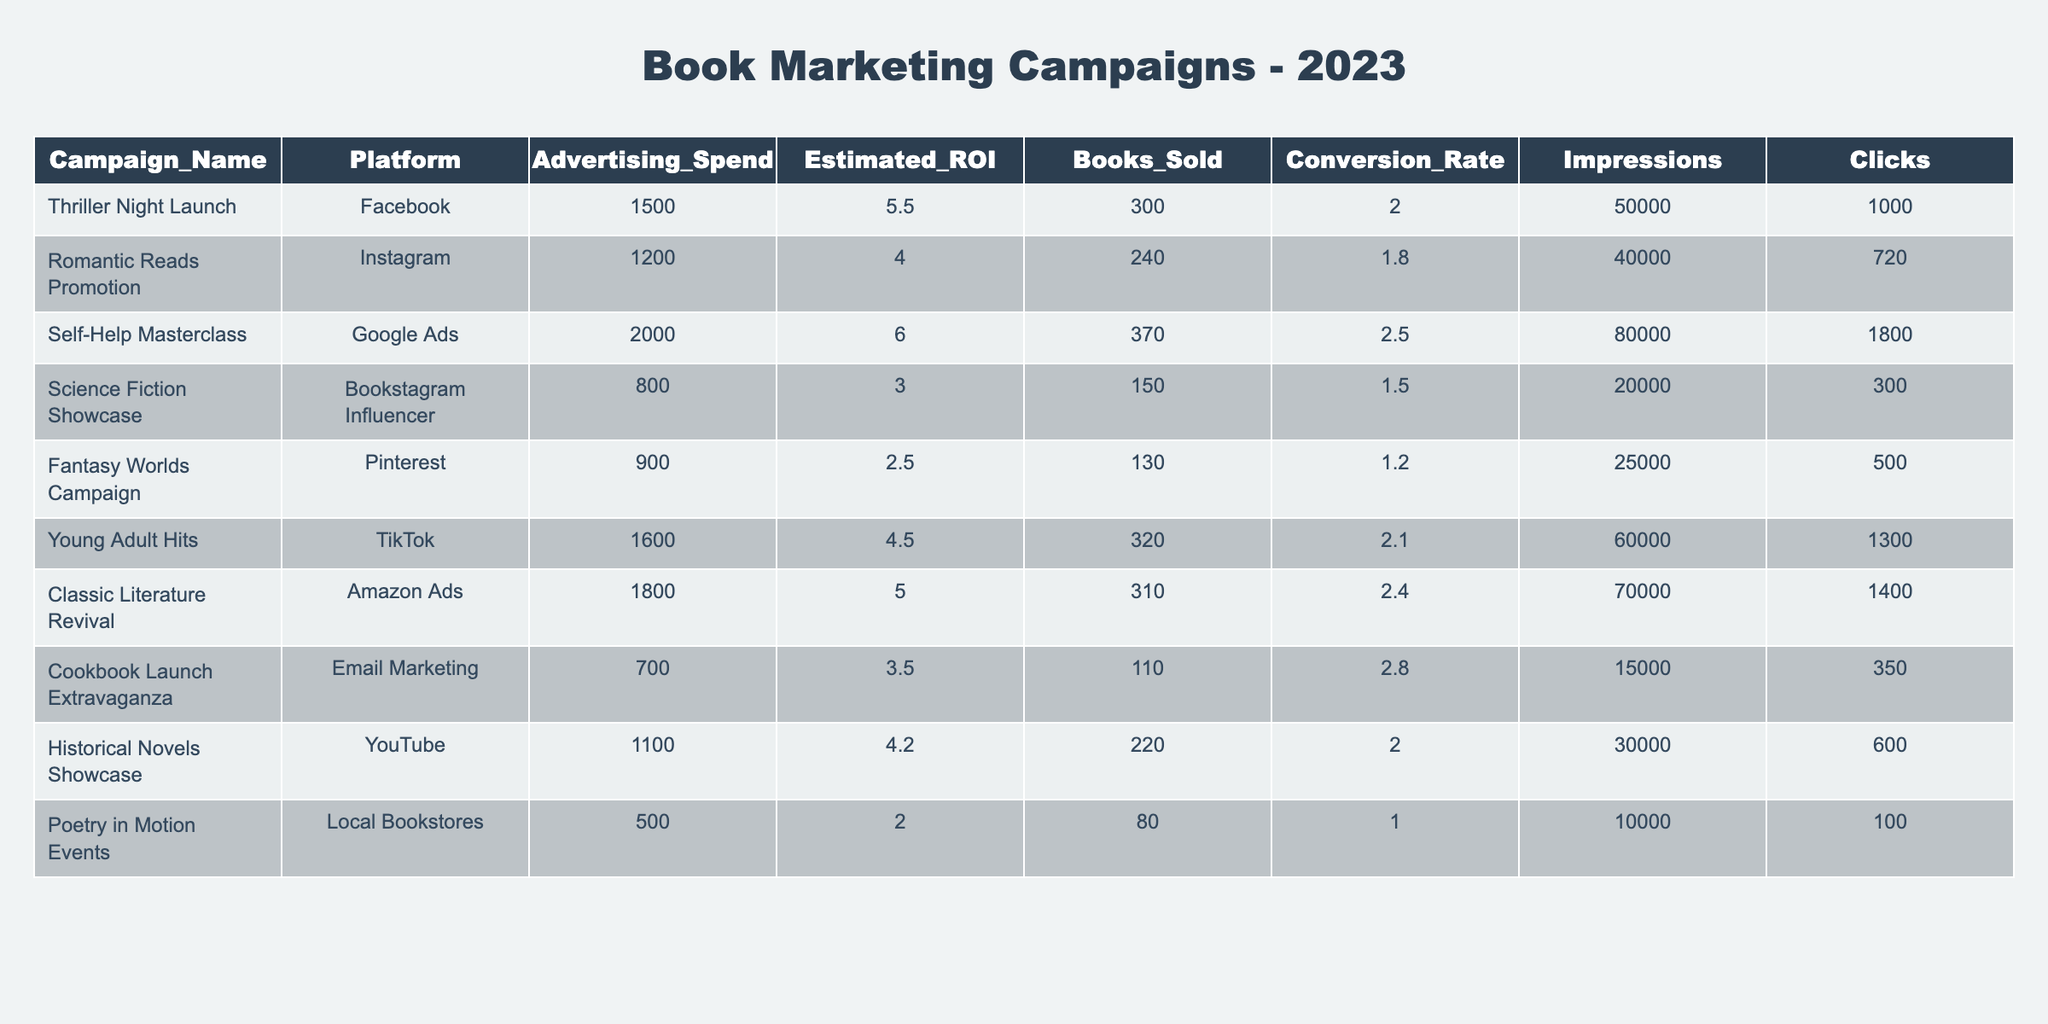What is the highest estimated ROI among the campaigns? From the table, I look at the "Estimated ROI" column and find that the highest value is 6.0 for the "Self-Help Masterclass" campaign.
Answer: 6.0 Which campaign had the least advertising spend? I check the "Advertising Spend" column and find that the "Poetry in Motion Events" campaign has the lowest value of 500.
Answer: 500 How many books were sold in the "Classic Literature Revival" campaign? I refer to the "Books Sold" column for the "Classic Literature Revival" campaign and see that 310 books were sold.
Answer: 310 What is the average advertising spend across all campaigns? I sum up the values in the "Advertising Spend" column (1500 + 1200 + 2000 + 800 + 900 + 1600 + 1800 + 700 + 1100 + 500) which equals 11,100, then divide by the number of campaigns (10), getting the average as 1,110.
Answer: 1110 Is the conversion rate for the "Cookbook Launch Extravaganza" campaign higher than that of the "Fantasy Worlds Campaign"? The "Cookbook Launch Extravaganza" has a conversion rate of 2.8 while the "Fantasy Worlds Campaign" has a conversion rate of 1.2. Since 2.8 is greater than 1.2, the statement is true.
Answer: Yes What is the total number of books sold for campaigns with an advertising spend above 1000? I identify the campaigns with an advertising spend above 1000: "Thriller Night Launch" (300), "Self-Help Masterclass" (370), "Young Adult Hits" (320), and "Classic Literature Revival" (310). I add those books sold: 300 + 370 + 320 + 310 = 1300.
Answer: 1300 Which platform generated the most impressions? Looking at the "Impressions" column, I see that the "Self-Help Masterclass" campaign had the highest impressions at 80,000.
Answer: 80000 What is the difference in books sold between the "Historical Novels Showcase" and the "Poetry in Motion Events"? "Historical Novels Showcase" sold 220 books and "Poetry in Motion Events" sold 80 books. The difference is 220 - 80 = 140.
Answer: 140 How does the average estimated ROI of campaigns on social media platforms compare to those on other platforms? I identify the campaigns on social media platforms ("Facebook", "Instagram", "TikTok") and calculate their average estimated ROI: (5.5 + 4.0 + 4.5)/3 = 4.67. Non-social media campaigns show an average estimated ROI of (6.0 + 3.0 + 2.5 + 5.0 + 3.5 + 4.2)/7 = 4.14. Since 4.67 > 4.14, social media campaigns have a better average ROI.
Answer: Social media campaigns have better average ROI Is there a campaign that had both a low advertising spend and low books sold? The "Poetry in Motion Events" campaign has an advertising spend of 500 and books sold is 80, which indicates low values for both. Hence, this condition is satisfied.
Answer: Yes 